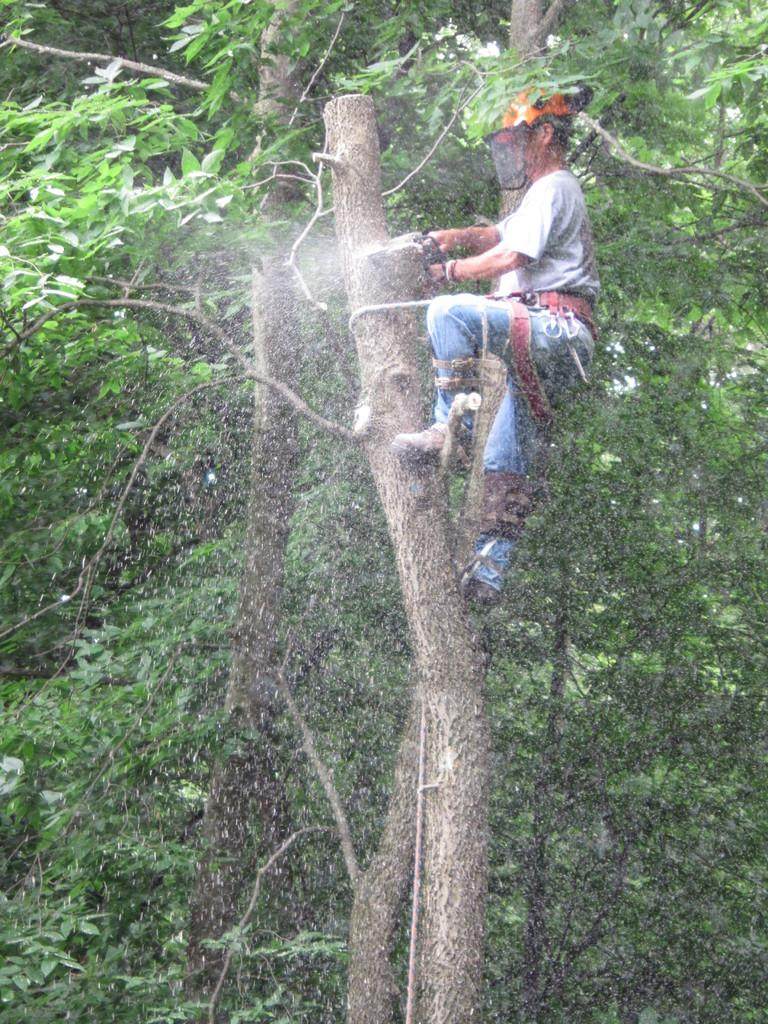Who is the person in the image? There is a man in the image. What is the man doing in the image? The man is climbing a tree and cutting it. What is the color of the trees in the image? The trees in the image are green. What type of stamp can be seen on the tree in the image? There is no stamp present on the tree in the image. What book is the man reading while climbing the tree? The man is not reading a book in the image; he is cutting the tree branches. 